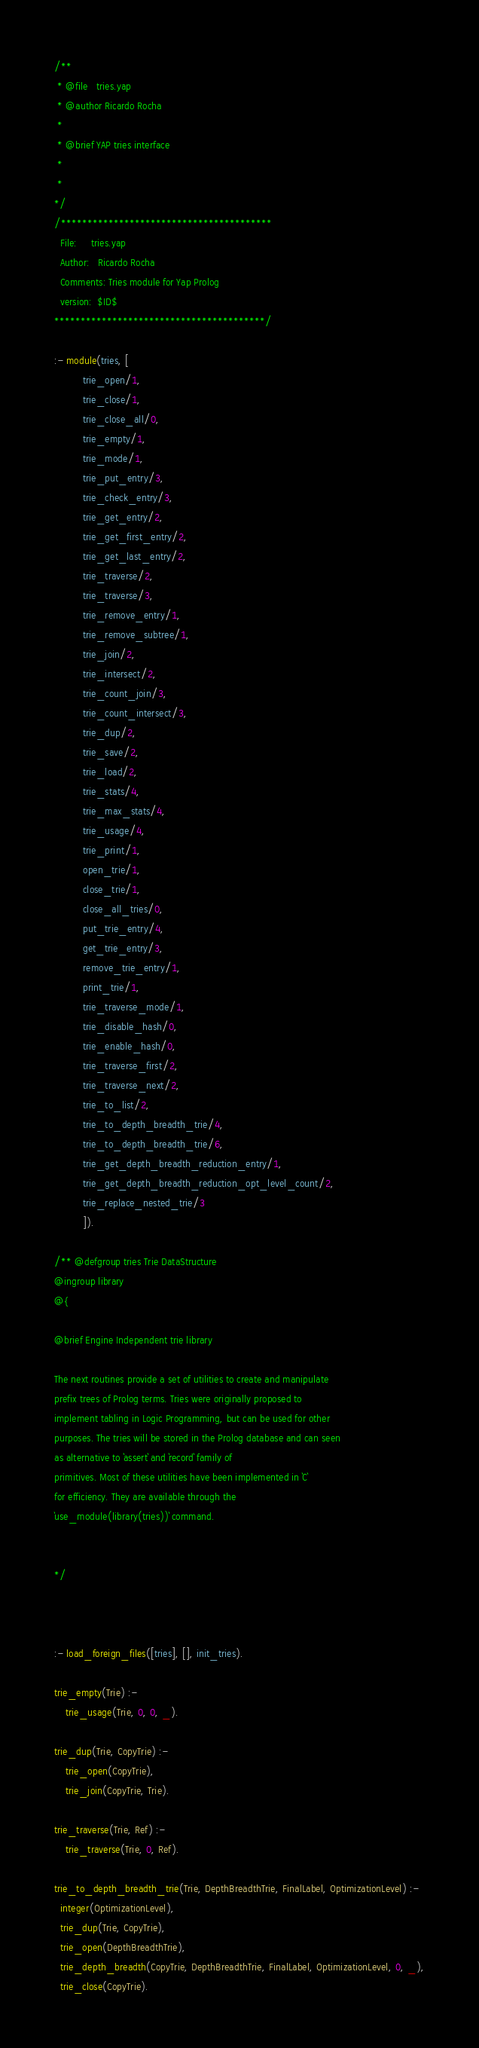Convert code to text. <code><loc_0><loc_0><loc_500><loc_500><_Prolog_>/**
 * @file   tries.yap
 * @author Ricardo Rocha
 * 
 * @brief YAP tries interface  
 * 
 * 
*/
/****************************************
  File:     tries.yap
  Author:   Ricardo Rocha
  Comments: Tries module for Yap Prolog
  version:  $ID$
****************************************/

:- module(tries, [
		  trie_open/1,
		  trie_close/1,
		  trie_close_all/0,
		  trie_empty/1,
		  trie_mode/1,
		  trie_put_entry/3,
		  trie_check_entry/3,
		  trie_get_entry/2,
		  trie_get_first_entry/2,
		  trie_get_last_entry/2,
		  trie_traverse/2,
		  trie_traverse/3,
		  trie_remove_entry/1,
		  trie_remove_subtree/1,
		  trie_join/2,
		  trie_intersect/2,
		  trie_count_join/3,
		  trie_count_intersect/3,
		  trie_dup/2,
		  trie_save/2,
		  trie_load/2,
		  trie_stats/4,
		  trie_max_stats/4,
		  trie_usage/4,
		  trie_print/1,
		  open_trie/1,
		  close_trie/1,
		  close_all_tries/0,
		  put_trie_entry/4,
		  get_trie_entry/3,
		  remove_trie_entry/1,
		  print_trie/1,
          trie_traverse_mode/1,
          trie_disable_hash/0,
          trie_enable_hash/0,
          trie_traverse_first/2,
          trie_traverse_next/2,
          trie_to_list/2,
          trie_to_depth_breadth_trie/4,
          trie_to_depth_breadth_trie/6,
          trie_get_depth_breadth_reduction_entry/1,
          trie_get_depth_breadth_reduction_opt_level_count/2,
          trie_replace_nested_trie/3
          ]).

/** @defgroup tries Trie DataStructure
@ingroup library
@{

@brief Engine Independent trie library

The next routines provide a set of utilities to create and manipulate
prefix trees of Prolog terms. Tries were originally proposed to
implement tabling in Logic Programming, but can be used for other
purposes. The tries will be stored in the Prolog database and can seen
as alternative to `assert` and `record` family of
primitives. Most of these utilities have been implemented in `C`
for efficiency. They are available through the
`use_module(library(tries))` command.

 
*/



:- load_foreign_files([tries], [], init_tries).

trie_empty(Trie) :-
	trie_usage(Trie, 0, 0, _).

trie_dup(Trie, CopyTrie) :-
	trie_open(CopyTrie),
	trie_join(CopyTrie, Trie).

trie_traverse(Trie, Ref) :- 
	trie_traverse(Trie, 0, Ref).

trie_to_depth_breadth_trie(Trie, DepthBreadthTrie, FinalLabel, OptimizationLevel) :-
  integer(OptimizationLevel),
  trie_dup(Trie, CopyTrie),
  trie_open(DepthBreadthTrie),
  trie_depth_breadth(CopyTrie, DepthBreadthTrie, FinalLabel, OptimizationLevel, 0, _),
  trie_close(CopyTrie).
</code> 